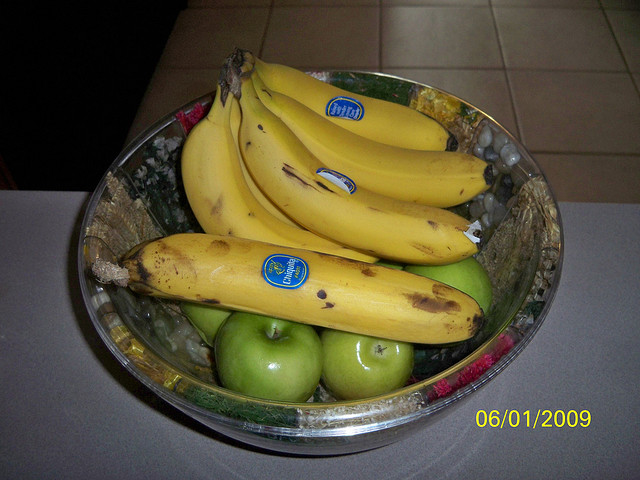Read and extract the text from this image. 06 /01 2009 Chiquita 